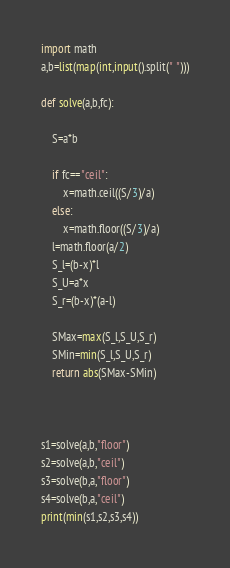Convert code to text. <code><loc_0><loc_0><loc_500><loc_500><_Python_>import math
a,b=list(map(int,input().split(" ")))

def solve(a,b,fc):

    S=a*b

    if fc=="ceil":
        x=math.ceil((S/3)/a)
    else:
        x=math.floor((S/3)/a)
    l=math.floor(a/2)
    S_l=(b-x)*l
    S_U=a*x
    S_r=(b-x)*(a-l)

    SMax=max(S_l,S_U,S_r)
    SMin=min(S_l,S_U,S_r)
    return abs(SMax-SMin)



s1=solve(a,b,"floor")
s2=solve(a,b,"ceil")
s3=solve(b,a,"floor")
s4=solve(b,a,"ceil")
print(min(s1,s2,s3,s4))
</code> 